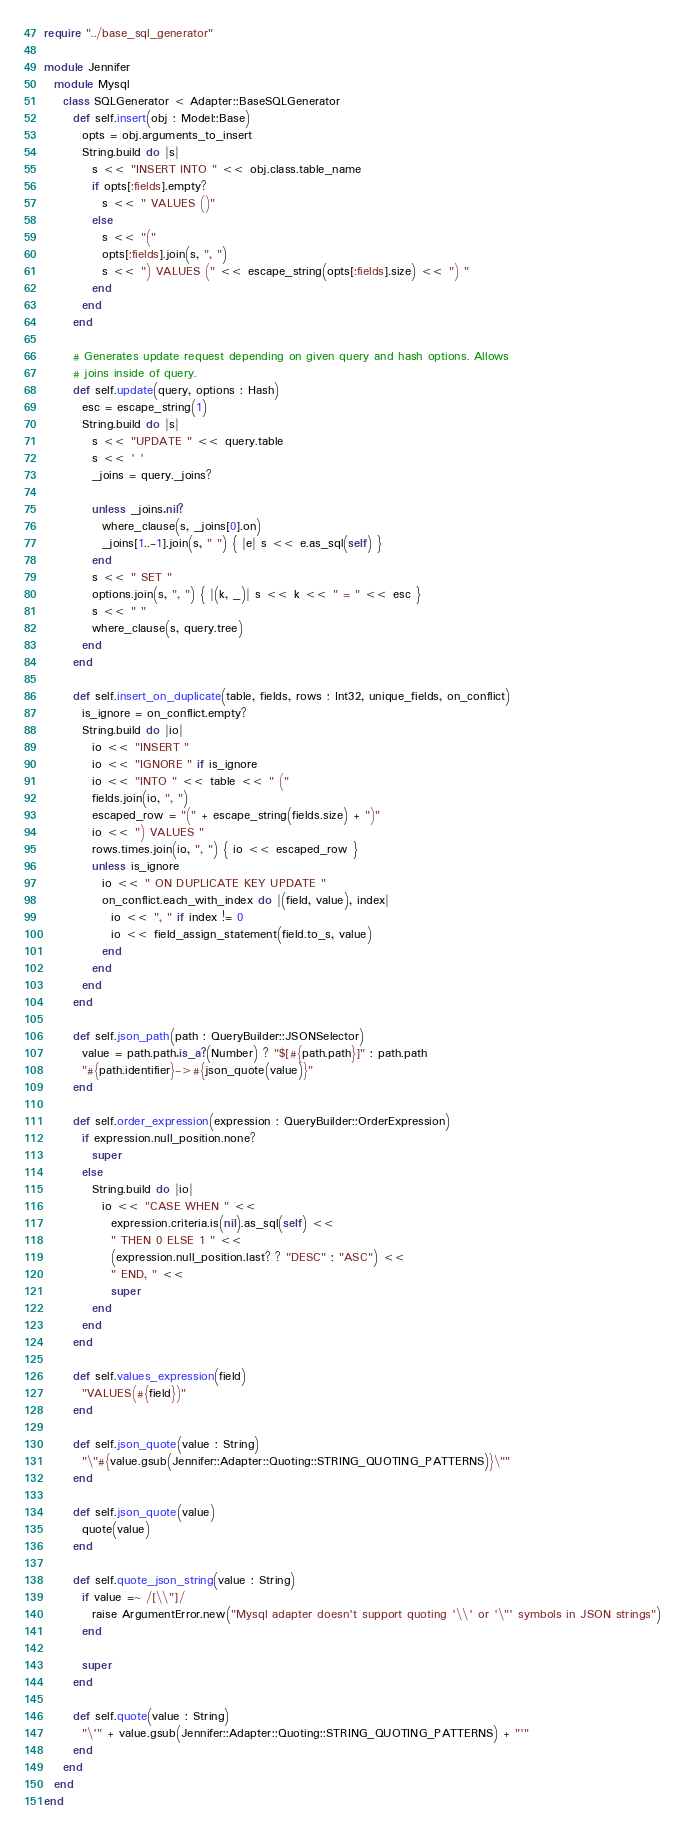<code> <loc_0><loc_0><loc_500><loc_500><_Crystal_>require "../base_sql_generator"

module Jennifer
  module Mysql
    class SQLGenerator < Adapter::BaseSQLGenerator
      def self.insert(obj : Model::Base)
        opts = obj.arguments_to_insert
        String.build do |s|
          s << "INSERT INTO " << obj.class.table_name
          if opts[:fields].empty?
            s << " VALUES ()"
          else
            s << "("
            opts[:fields].join(s, ", ")
            s << ") VALUES (" << escape_string(opts[:fields].size) << ") "
          end
        end
      end

      # Generates update request depending on given query and hash options. Allows
      # joins inside of query.
      def self.update(query, options : Hash)
        esc = escape_string(1)
        String.build do |s|
          s << "UPDATE " << query.table
          s << ' '
          _joins = query._joins?

          unless _joins.nil?
            where_clause(s, _joins[0].on)
            _joins[1..-1].join(s, " ") { |e| s << e.as_sql(self) }
          end
          s << " SET "
          options.join(s, ", ") { |(k, _)| s << k << " = " << esc }
          s << " "
          where_clause(s, query.tree)
        end
      end

      def self.insert_on_duplicate(table, fields, rows : Int32, unique_fields, on_conflict)
        is_ignore = on_conflict.empty?
        String.build do |io|
          io << "INSERT "
          io << "IGNORE " if is_ignore
          io << "INTO " << table << " ("
          fields.join(io, ", ")
          escaped_row = "(" + escape_string(fields.size) + ")"
          io << ") VALUES "
          rows.times.join(io, ", ") { io << escaped_row }
          unless is_ignore
            io << " ON DUPLICATE KEY UPDATE "
            on_conflict.each_with_index do |(field, value), index|
              io << ", " if index != 0
              io << field_assign_statement(field.to_s, value)
            end
          end
        end
      end

      def self.json_path(path : QueryBuilder::JSONSelector)
        value = path.path.is_a?(Number) ? "$[#{path.path}]" : path.path
        "#{path.identifier}->#{json_quote(value)}"
      end

      def self.order_expression(expression : QueryBuilder::OrderExpression)
        if expression.null_position.none?
          super
        else
          String.build do |io|
            io << "CASE WHEN " <<
              expression.criteria.is(nil).as_sql(self) <<
              " THEN 0 ELSE 1 " <<
              (expression.null_position.last? ? "DESC" : "ASC") <<
              " END, " <<
              super
          end
        end
      end

      def self.values_expression(field)
        "VALUES(#{field})"
      end

      def self.json_quote(value : String)
        "\"#{value.gsub(Jennifer::Adapter::Quoting::STRING_QUOTING_PATTERNS)}\""
      end

      def self.json_quote(value)
        quote(value)
      end

      def self.quote_json_string(value : String)
        if value =~ /[\\"]/
          raise ArgumentError.new("Mysql adapter doesn't support quoting '\\' or '\"' symbols in JSON strings")
        end

        super
      end

      def self.quote(value : String)
        "\'" + value.gsub(Jennifer::Adapter::Quoting::STRING_QUOTING_PATTERNS) + "'"
      end
    end
  end
end
</code> 